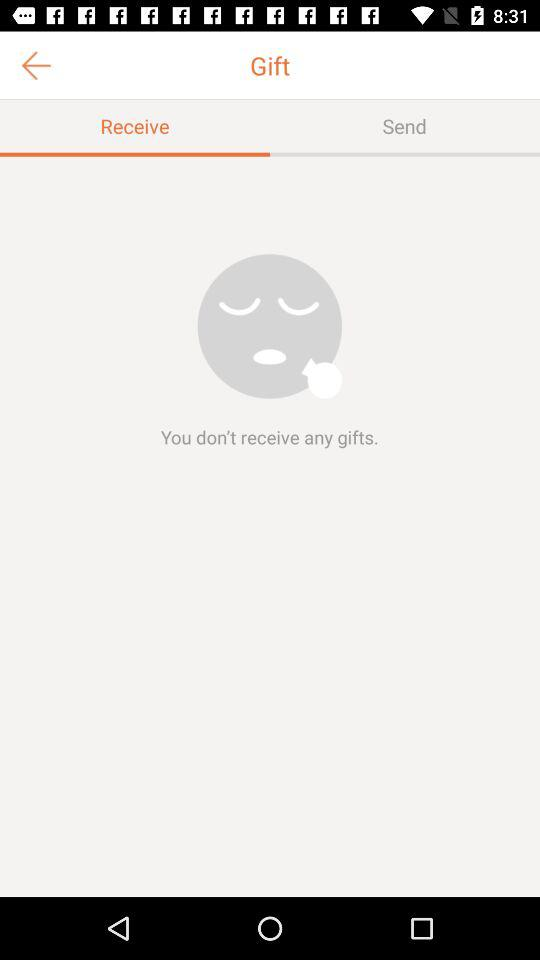Which tab is selected? The selected tab is "Receive". 